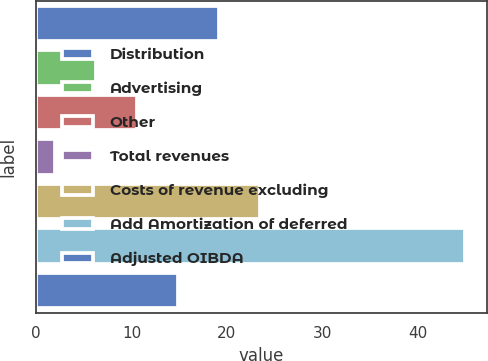Convert chart to OTSL. <chart><loc_0><loc_0><loc_500><loc_500><bar_chart><fcel>Distribution<fcel>Advertising<fcel>Other<fcel>Total revenues<fcel>Costs of revenue excluding<fcel>Add Amortization of deferred<fcel>Adjusted OIBDA<nl><fcel>19.2<fcel>6.3<fcel>10.6<fcel>2<fcel>23.5<fcel>45<fcel>14.9<nl></chart> 